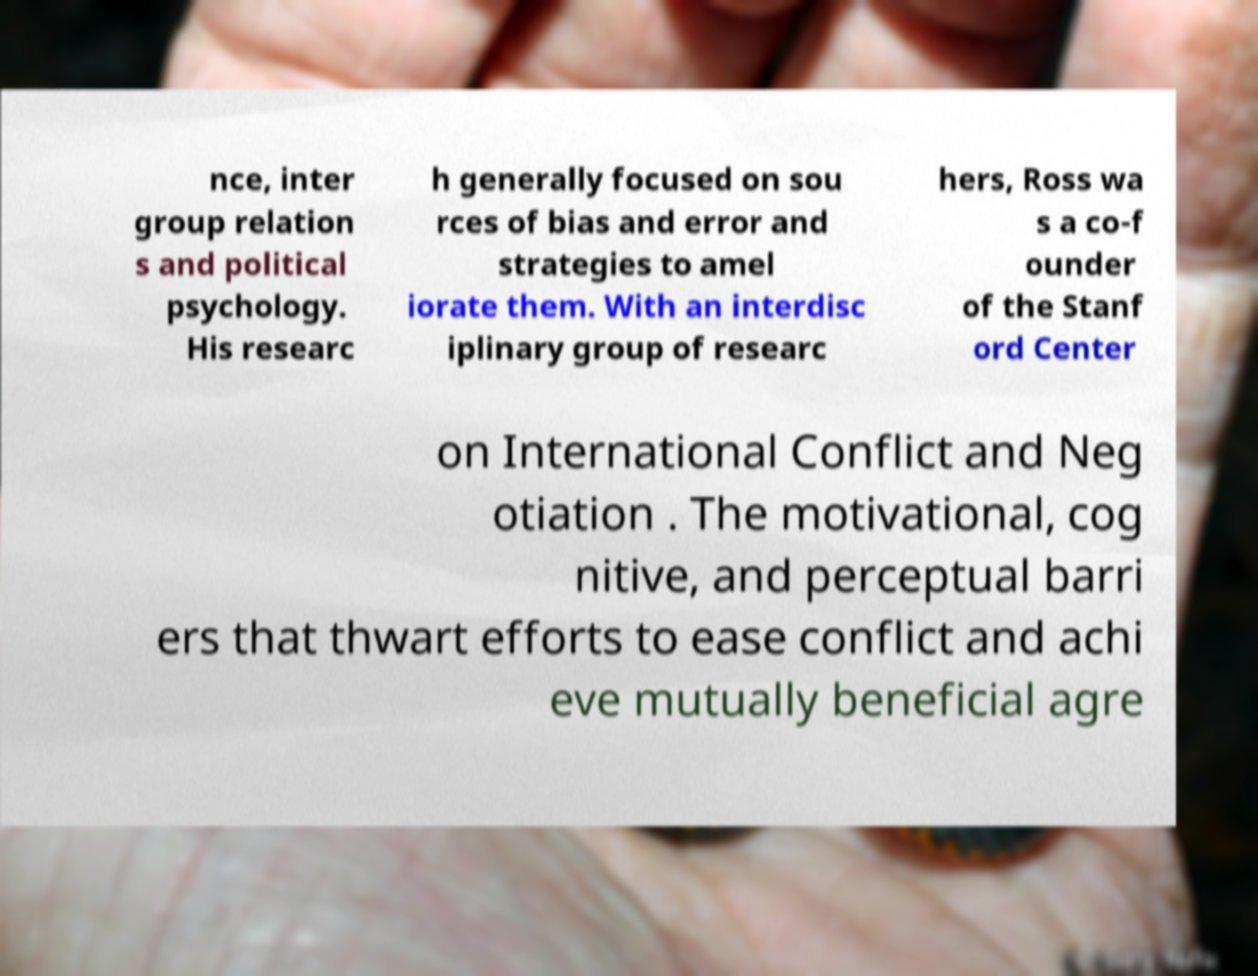Please read and relay the text visible in this image. What does it say? nce, inter group relation s and political psychology. His researc h generally focused on sou rces of bias and error and strategies to amel iorate them. With an interdisc iplinary group of researc hers, Ross wa s a co-f ounder of the Stanf ord Center on International Conflict and Neg otiation . The motivational, cog nitive, and perceptual barri ers that thwart efforts to ease conflict and achi eve mutually beneficial agre 